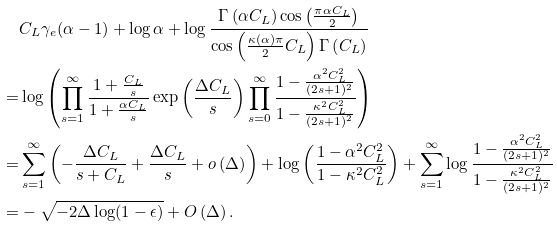<formula> <loc_0><loc_0><loc_500><loc_500>& C _ { L } \gamma _ { e } ( \alpha - 1 ) + \log \alpha + \log \frac { \Gamma \left ( \alpha C _ { L } \right ) \cos \left ( \frac { \pi \alpha C _ { L } } { 2 } \right ) } { \cos \left ( \frac { \kappa ( \alpha ) \pi } { 2 } C _ { L } \right ) \Gamma \left ( C _ { L } \right ) } \\ = & \log \left ( \prod _ { s = 1 } ^ { \infty } \frac { 1 + \frac { C _ { L } } { s } } { 1 + \frac { \alpha C _ { L } } { s } } \exp \left ( \frac { \Delta C _ { L } } { s } \right ) \prod _ { s = 0 } ^ { \infty } \frac { 1 - \frac { \alpha ^ { 2 } C _ { L } ^ { 2 } } { ( 2 s + 1 ) ^ { 2 } } } { 1 - \frac { \kappa ^ { 2 } C _ { L } ^ { 2 } } { ( 2 s + 1 ) ^ { 2 } } } \right ) \\ = & \sum _ { s = 1 } ^ { \infty } \left ( - \frac { \Delta C _ { L } } { s + C _ { L } } + \frac { \Delta C _ { L } } { s } + o \left ( \Delta \right ) \right ) + \log \left ( \frac { 1 - \alpha ^ { 2 } C _ { L } ^ { 2 } } { 1 - \kappa ^ { 2 } C _ { L } ^ { 2 } } \right ) + \sum _ { s = 1 } ^ { \infty } \log \frac { 1 - \frac { \alpha ^ { 2 } C _ { L } ^ { 2 } } { ( 2 s + 1 ) ^ { 2 } } } { 1 - \frac { \kappa ^ { 2 } C _ { L } ^ { 2 } } { ( 2 s + 1 ) ^ { 2 } } } \\ = & - \sqrt { - 2 \Delta \log ( 1 - \epsilon ) } + O \left ( \Delta \right ) .</formula> 